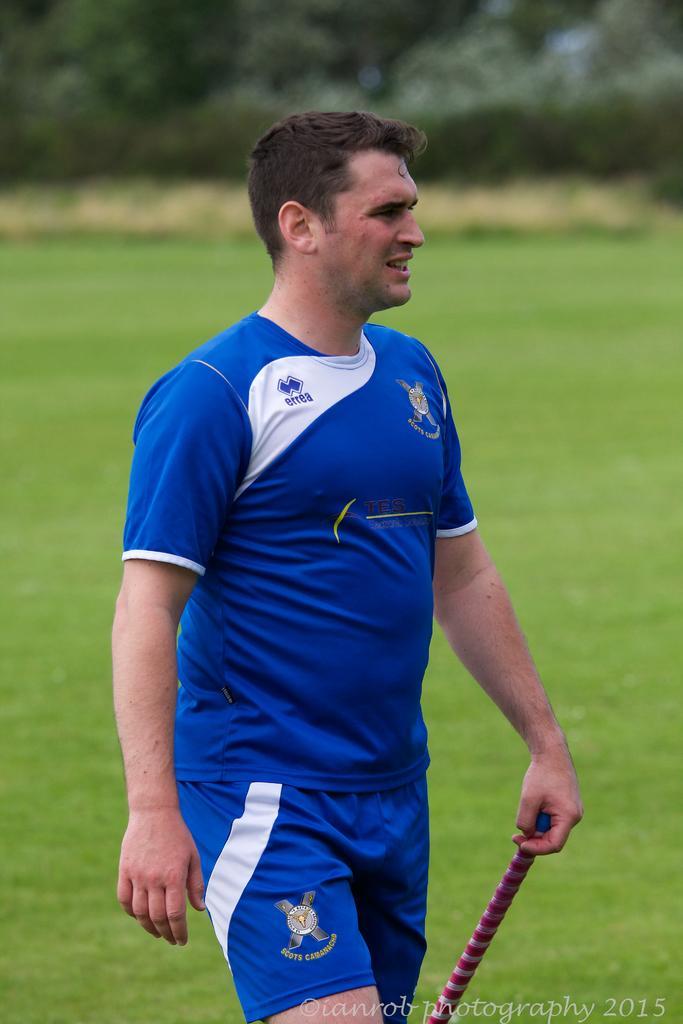Could you give a brief overview of what you see in this image? In the image there is a man, the background of the man is blur. 